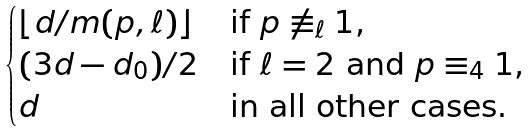<formula> <loc_0><loc_0><loc_500><loc_500>\begin{cases} \lfloor d / m ( p , \ell ) \rfloor & \text {if $p \not \equiv_{\ell} 1$,} \\ ( 3 d - d _ { 0 } ) / 2 & \text {if $\ell = 2$ and $p    \equiv_{4} 1$,} \\ d & \text {in all other cases.} \end{cases}</formula> 